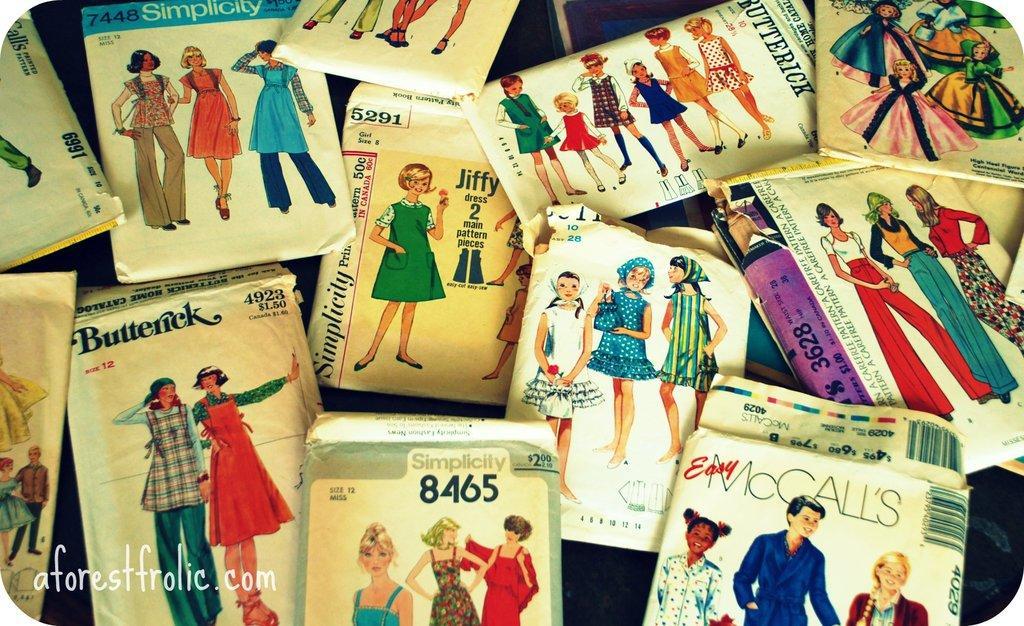Can you describe this image briefly? In this picture I can see number of papers on which there are depiction pictures of women and I can see something is written on each paper and I can see the watermark on the bottom left corner of this picture. 